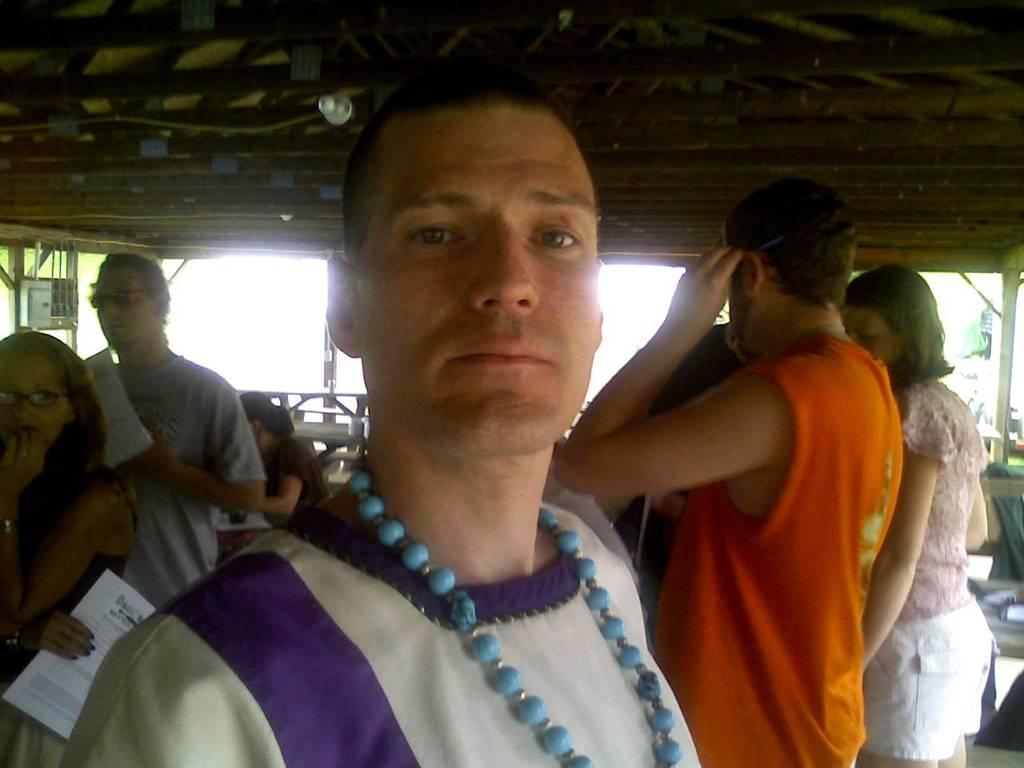Who is the main subject in the image? There is a man standing in the middle of the image. Are there any other people present in the image? Yes, there are people standing in the background of the image. What structure can be seen at the top of the image? There is a shed visible at the top of the image. What type of food is being served in the church in the image? There is no church or food present in the image; it features a man standing in the middle, people in the background, and a shed at the top. 